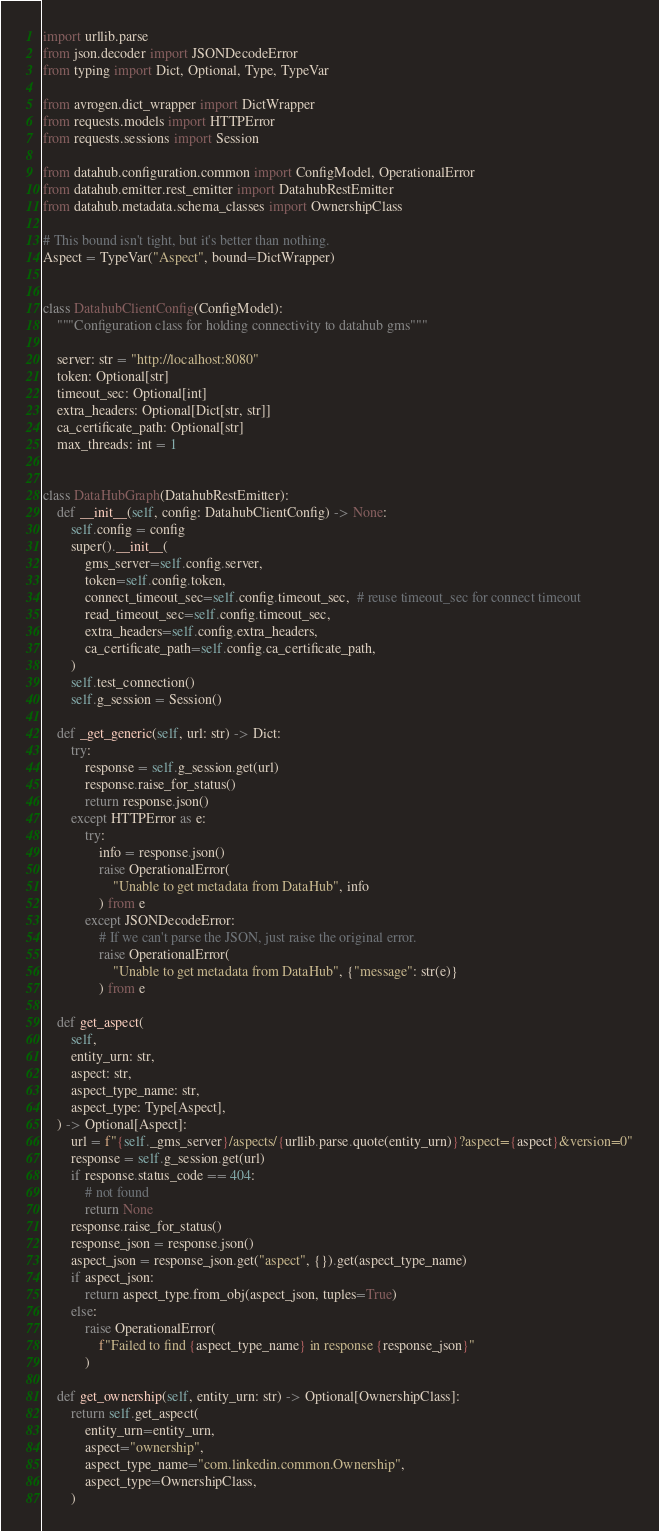<code> <loc_0><loc_0><loc_500><loc_500><_Python_>import urllib.parse
from json.decoder import JSONDecodeError
from typing import Dict, Optional, Type, TypeVar

from avrogen.dict_wrapper import DictWrapper
from requests.models import HTTPError
from requests.sessions import Session

from datahub.configuration.common import ConfigModel, OperationalError
from datahub.emitter.rest_emitter import DatahubRestEmitter
from datahub.metadata.schema_classes import OwnershipClass

# This bound isn't tight, but it's better than nothing.
Aspect = TypeVar("Aspect", bound=DictWrapper)


class DatahubClientConfig(ConfigModel):
    """Configuration class for holding connectivity to datahub gms"""

    server: str = "http://localhost:8080"
    token: Optional[str]
    timeout_sec: Optional[int]
    extra_headers: Optional[Dict[str, str]]
    ca_certificate_path: Optional[str]
    max_threads: int = 1


class DataHubGraph(DatahubRestEmitter):
    def __init__(self, config: DatahubClientConfig) -> None:
        self.config = config
        super().__init__(
            gms_server=self.config.server,
            token=self.config.token,
            connect_timeout_sec=self.config.timeout_sec,  # reuse timeout_sec for connect timeout
            read_timeout_sec=self.config.timeout_sec,
            extra_headers=self.config.extra_headers,
            ca_certificate_path=self.config.ca_certificate_path,
        )
        self.test_connection()
        self.g_session = Session()

    def _get_generic(self, url: str) -> Dict:
        try:
            response = self.g_session.get(url)
            response.raise_for_status()
            return response.json()
        except HTTPError as e:
            try:
                info = response.json()
                raise OperationalError(
                    "Unable to get metadata from DataHub", info
                ) from e
            except JSONDecodeError:
                # If we can't parse the JSON, just raise the original error.
                raise OperationalError(
                    "Unable to get metadata from DataHub", {"message": str(e)}
                ) from e

    def get_aspect(
        self,
        entity_urn: str,
        aspect: str,
        aspect_type_name: str,
        aspect_type: Type[Aspect],
    ) -> Optional[Aspect]:
        url = f"{self._gms_server}/aspects/{urllib.parse.quote(entity_urn)}?aspect={aspect}&version=0"
        response = self.g_session.get(url)
        if response.status_code == 404:
            # not found
            return None
        response.raise_for_status()
        response_json = response.json()
        aspect_json = response_json.get("aspect", {}).get(aspect_type_name)
        if aspect_json:
            return aspect_type.from_obj(aspect_json, tuples=True)
        else:
            raise OperationalError(
                f"Failed to find {aspect_type_name} in response {response_json}"
            )

    def get_ownership(self, entity_urn: str) -> Optional[OwnershipClass]:
        return self.get_aspect(
            entity_urn=entity_urn,
            aspect="ownership",
            aspect_type_name="com.linkedin.common.Ownership",
            aspect_type=OwnershipClass,
        )
</code> 